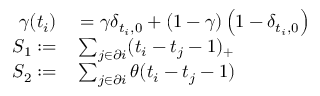<formula> <loc_0><loc_0><loc_500><loc_500>\begin{array} { r l } { \gamma ( t _ { i } ) } & = \gamma \delta _ { t _ { i } , 0 } + ( 1 - \gamma ) \left ( 1 - \delta _ { t _ { i } , 0 } \right ) } \\ { S _ { 1 } \colon = } & \sum _ { j \in \partial i } ( t _ { i } - t _ { j } - 1 ) _ { + } } \\ { S _ { 2 } \colon = } & \sum _ { j \in \partial i } \theta ( t _ { i } - t _ { j } - 1 ) } \end{array}</formula> 